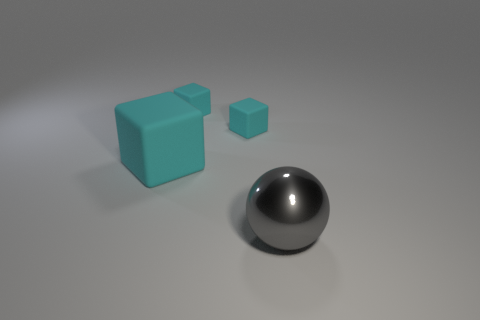What number of things are either big shiny cylinders or large objects to the left of the gray thing?
Your answer should be very brief. 1. Are there fewer gray objects on the left side of the large gray thing than cyan rubber cubes?
Your answer should be very brief. Yes. There is a object that is in front of the big object on the left side of the big thing that is in front of the big cyan object; what is its size?
Make the answer very short. Large. How many spheres are there?
Provide a succinct answer. 1. Is there any other thing that has the same size as the shiny object?
Your answer should be compact. Yes. Is the gray ball made of the same material as the big cube?
Provide a short and direct response. No. Is the number of tiny purple cubes less than the number of shiny things?
Your answer should be very brief. Yes. How many rubber objects are either tiny cyan things or large gray objects?
Offer a terse response. 2. There is a big object that is behind the big gray object; are there any gray metal things to the left of it?
Your response must be concise. No. Is the material of the big thing that is behind the large gray metal ball the same as the gray object?
Provide a succinct answer. No. 